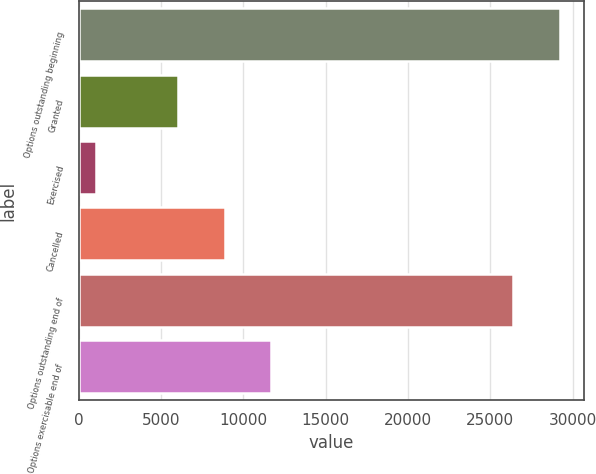<chart> <loc_0><loc_0><loc_500><loc_500><bar_chart><fcel>Options outstanding beginning<fcel>Granted<fcel>Exercised<fcel>Cancelled<fcel>Options outstanding end of<fcel>Options exercisable end of<nl><fcel>29210.8<fcel>6065<fcel>1049<fcel>8872.8<fcel>26403<fcel>11680.6<nl></chart> 